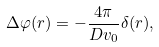Convert formula to latex. <formula><loc_0><loc_0><loc_500><loc_500>\Delta \varphi ( { r } ) = - \frac { 4 \pi } { D v _ { 0 } } \delta ( { r } ) ,</formula> 